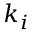<formula> <loc_0><loc_0><loc_500><loc_500>k _ { i }</formula> 